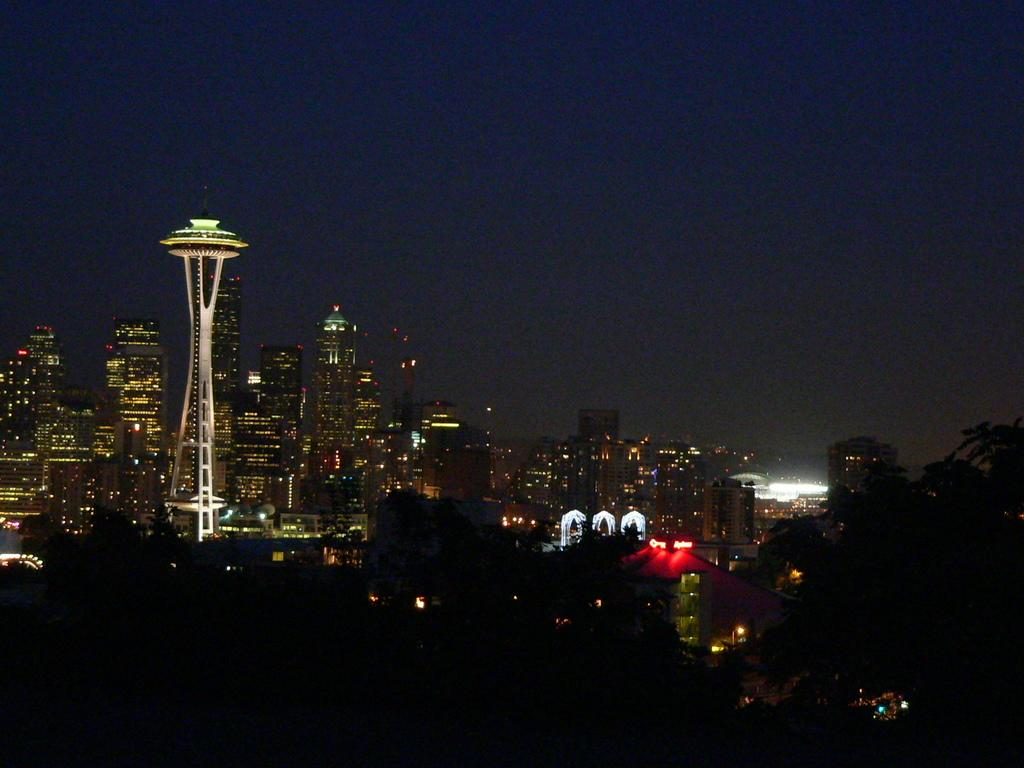What type of view is depicted in the image? The image shows a night view of buildings. What feature do the buildings have? The buildings have lights. What type of buildings can be seen in the background? There are tower buildings visible in the background. What part of the natural environment is visible in the image? The sky is visible in the image. What type of railway can be seen in the image? There is no railway present in the image; it features a night view of buildings with lights. What type of blade is being used to cut the coal in the image? There is no coal or blade present in the image; it only shows a night view of buildings with lights. 